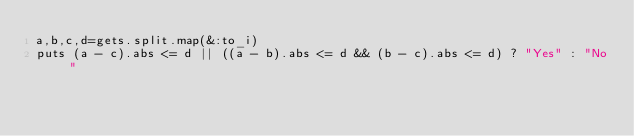Convert code to text. <code><loc_0><loc_0><loc_500><loc_500><_Ruby_>a,b,c,d=gets.split.map(&:to_i)
puts (a - c).abs <= d || ((a - b).abs <= d && (b - c).abs <= d) ? "Yes" : "No"</code> 